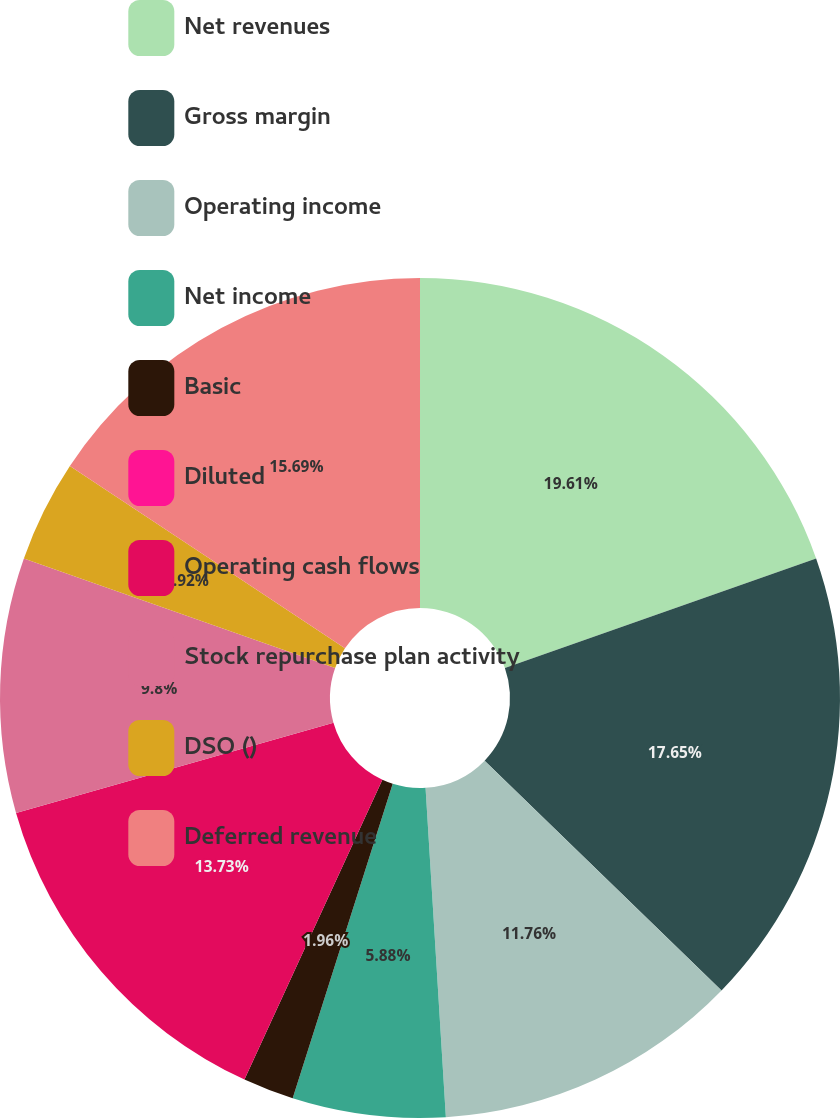<chart> <loc_0><loc_0><loc_500><loc_500><pie_chart><fcel>Net revenues<fcel>Gross margin<fcel>Operating income<fcel>Net income<fcel>Basic<fcel>Diluted<fcel>Operating cash flows<fcel>Stock repurchase plan activity<fcel>DSO ()<fcel>Deferred revenue<nl><fcel>19.6%<fcel>17.64%<fcel>11.76%<fcel>5.88%<fcel>1.96%<fcel>0.0%<fcel>13.72%<fcel>9.8%<fcel>3.92%<fcel>15.68%<nl></chart> 